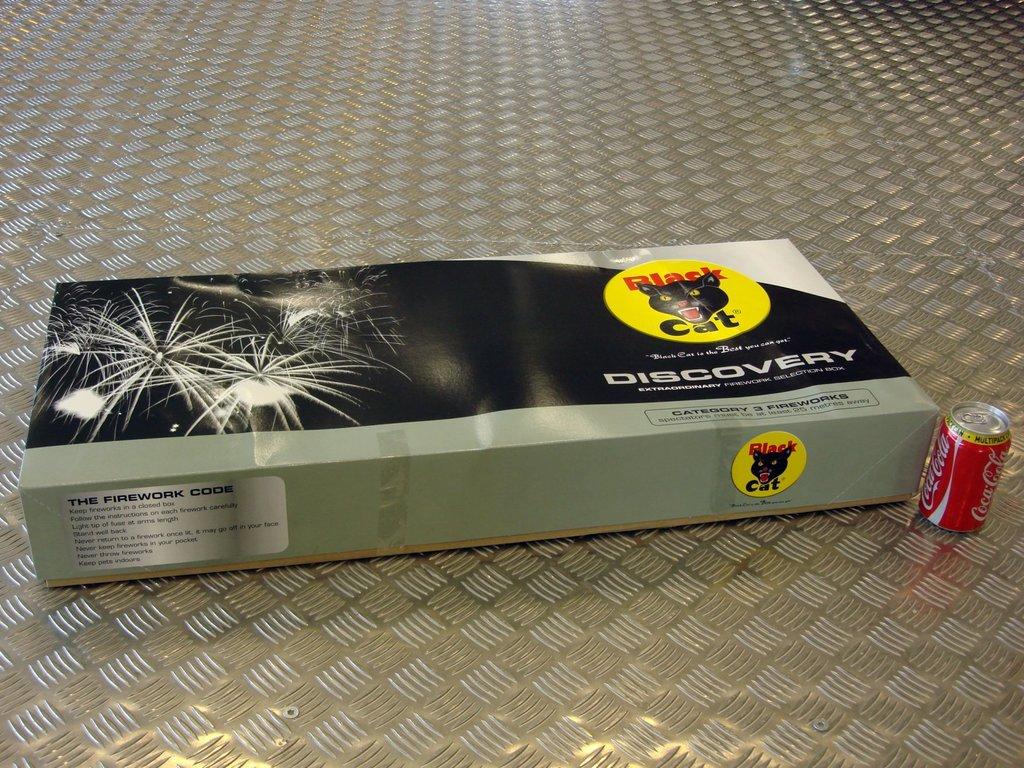What brand of fireworks is this product?
Provide a succinct answer. Black cat. 